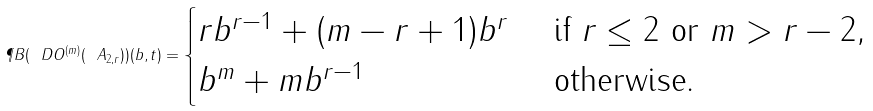<formula> <loc_0><loc_0><loc_500><loc_500>\P B ( \ D O ^ { ( m ) } ( \ A _ { 2 , r } ) ) ( b , t ) = \begin{cases} r b ^ { r - 1 } + ( m - r + 1 ) b ^ { r } & \text { if } r \leq 2 \text { or } m > r - 2 , \\ b ^ { m } + m b ^ { r - 1 } & \text { otherwise.} \end{cases}</formula> 